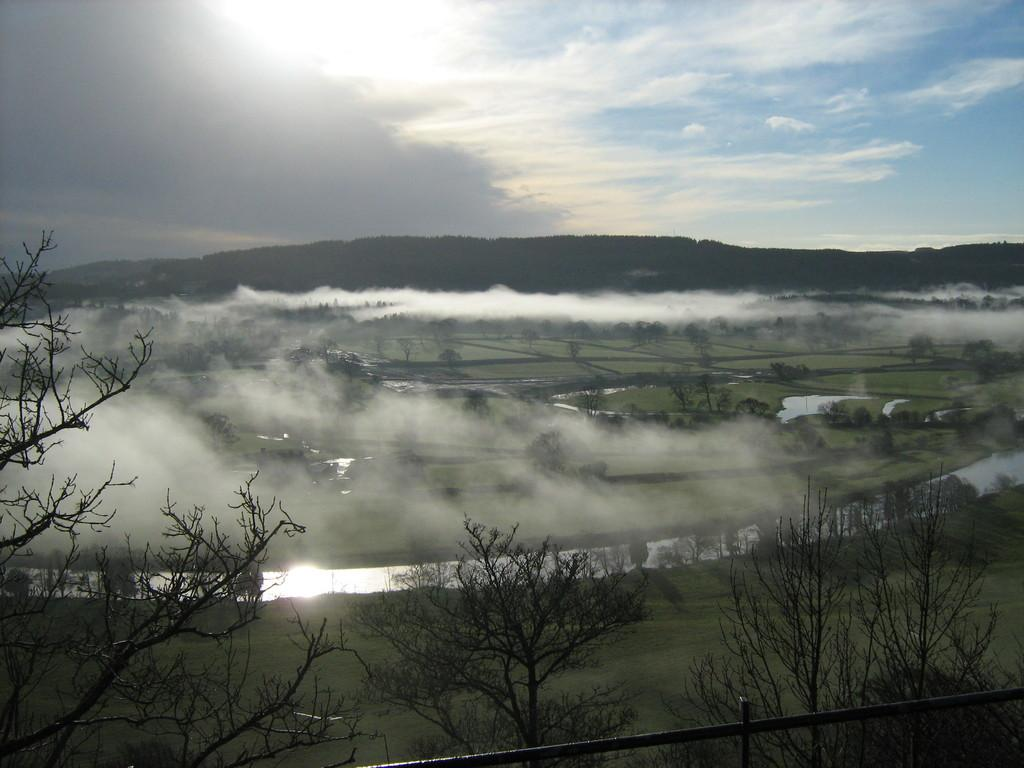What type of vegetation is at the bottom of the image? There are trees at the bottom of the image. What is located at the bottom of the image alongside the trees? There is a fence at the bottom of the image. What feature is present in the center of the image? There is a canal in the center of the image. What atmospheric condition is visible in the image? Mist is visible in the image. What type of terrain is present in the image? There are hills in the image. What is visible at the top of the image? The sky is visible at the top of the image. What type of milk is being poured into the canal in the image? There is no milk being poured into the canal in the image. What type of suit is the person wearing while standing on the hills in the image? There are no people or suits present in the image. 